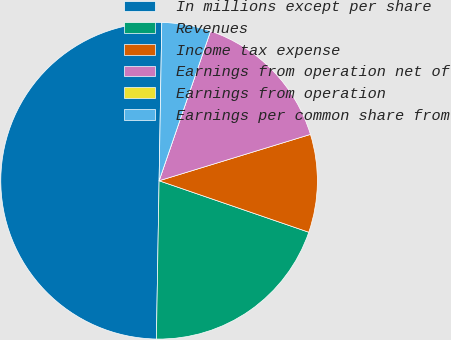Convert chart. <chart><loc_0><loc_0><loc_500><loc_500><pie_chart><fcel>In millions except per share<fcel>Revenues<fcel>Income tax expense<fcel>Earnings from operation net of<fcel>Earnings from operation<fcel>Earnings per common share from<nl><fcel>50.0%<fcel>20.0%<fcel>10.0%<fcel>15.0%<fcel>0.0%<fcel>5.0%<nl></chart> 